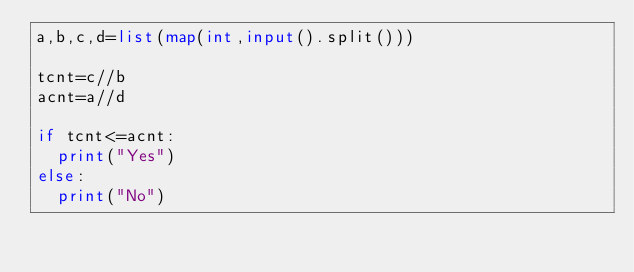<code> <loc_0><loc_0><loc_500><loc_500><_Python_>a,b,c,d=list(map(int,input().split()))

tcnt=c//b
acnt=a//d

if tcnt<=acnt:
	print("Yes")
else:
	print("No")</code> 